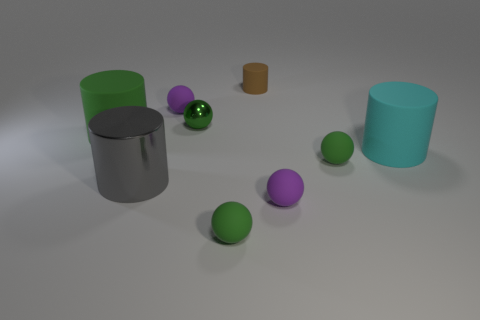Could you tell me the total number of spherical objects in the image, regardless of their size? Certainly, there are five spherical objects in the image, which include two purple and three green spheres. 